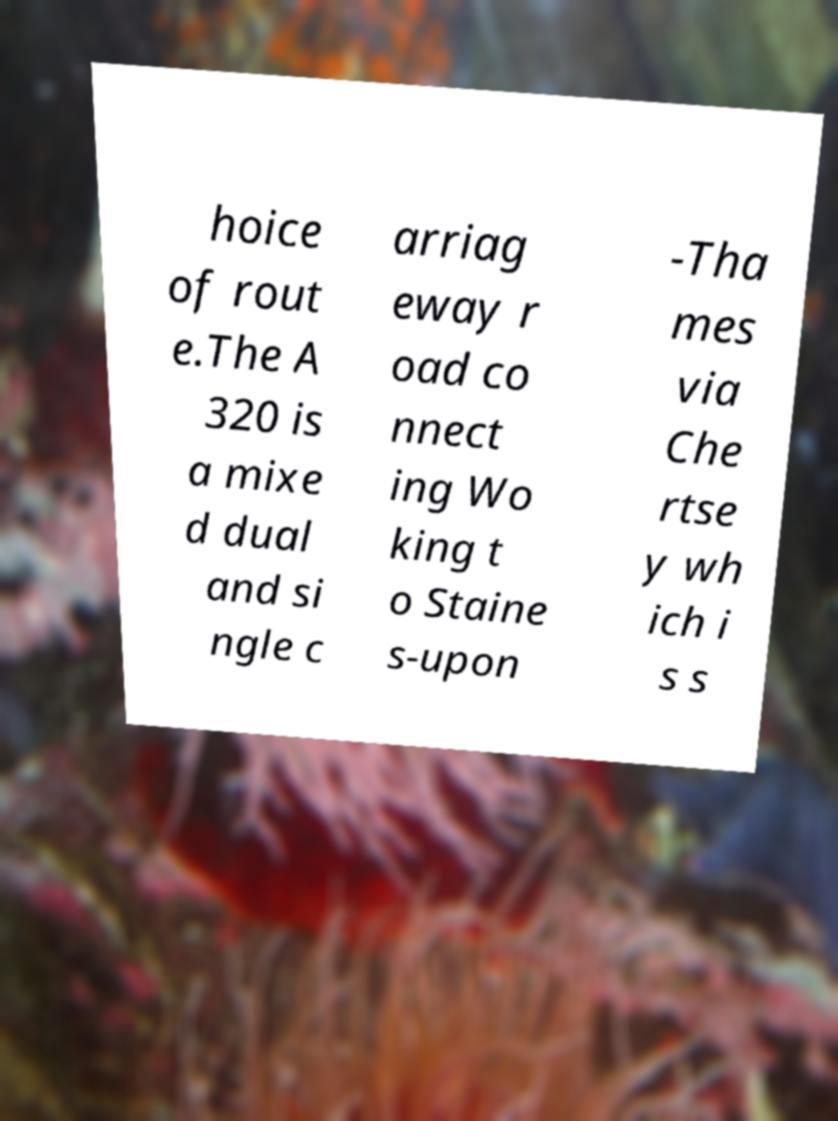For documentation purposes, I need the text within this image transcribed. Could you provide that? hoice of rout e.The A 320 is a mixe d dual and si ngle c arriag eway r oad co nnect ing Wo king t o Staine s-upon -Tha mes via Che rtse y wh ich i s s 